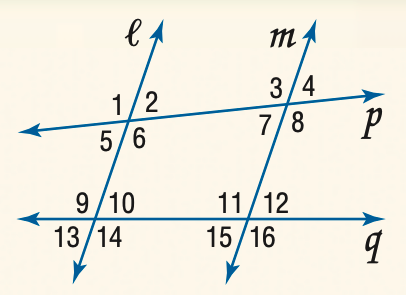Answer the mathemtical geometry problem and directly provide the correct option letter.
Question: Find the measure of \angle 6 if l \parallel m and m \angle 1 = 105.
Choices: A: 75 B: 85 C: 95 D: 105 D 